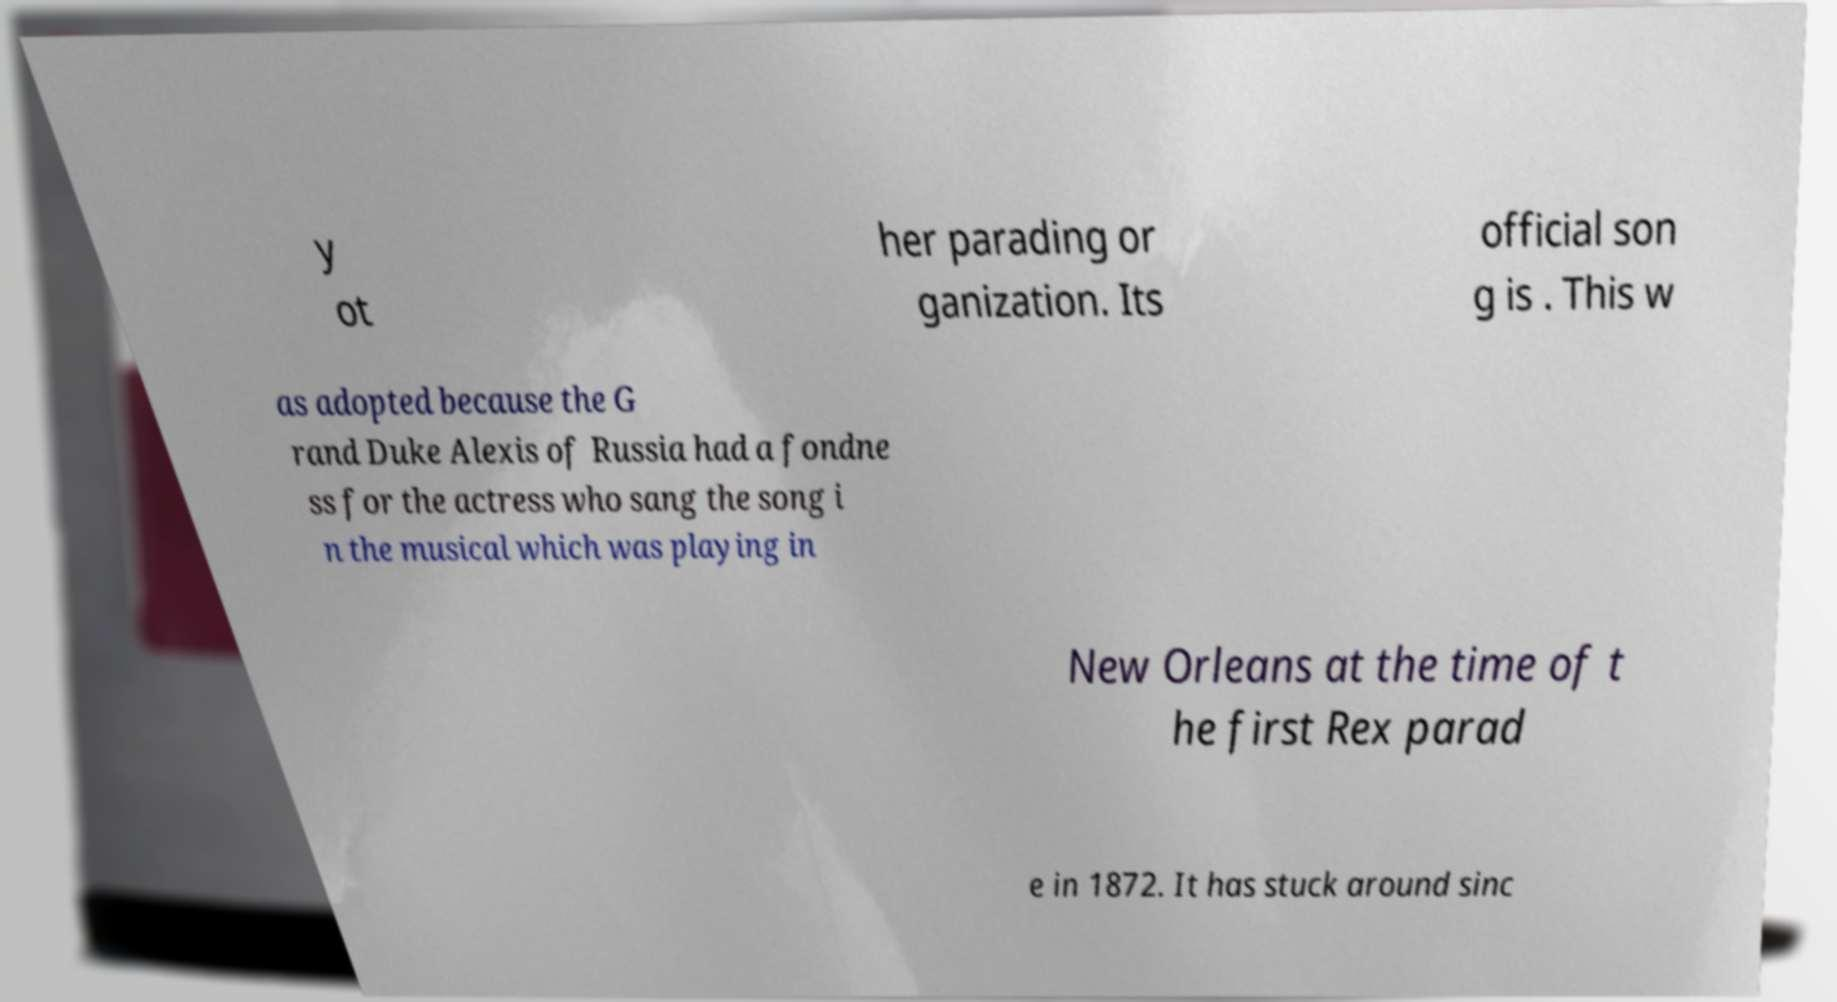I need the written content from this picture converted into text. Can you do that? y ot her parading or ganization. Its official son g is . This w as adopted because the G rand Duke Alexis of Russia had a fondne ss for the actress who sang the song i n the musical which was playing in New Orleans at the time of t he first Rex parad e in 1872. It has stuck around sinc 